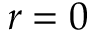Convert formula to latex. <formula><loc_0><loc_0><loc_500><loc_500>r = 0</formula> 